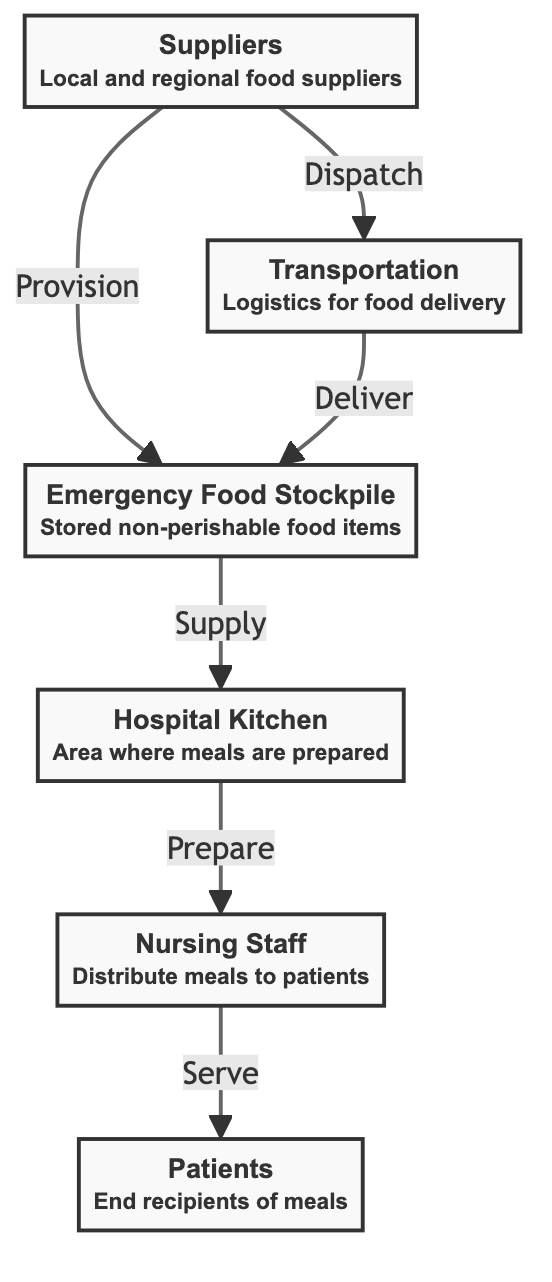What is the first step in the emergency food supply chain? The first step in the emergency food supply chain is the "Emergency Food Stockpile," where non-perishable food items are stored. This is represented as node 1 in the diagram.
Answer: Emergency Food Stockpile How many nodes are there in the diagram? The diagram contains a total of six nodes, which are: Emergency Food Stockpile, Suppliers, Transportation, Hospital Kitchen, Nursing Staff, and Patients.
Answer: 6 What role do local and regional food suppliers play in the chain? Local and regional food suppliers are responsible for the provision of food to the emergency food stockpile, as indicated by the arrow showing the provision relationship between node 2 (Suppliers) and node 1 (Emergency Food Stockpile).
Answer: Provision Which node directly supplies meals to the hospital kitchen? The node that directly supplies meals to the hospital kitchen is the "Emergency Food Stockpile," as indicated by the arrow showing the supply relationship between node 1 and node 4 (Hospital Kitchen).
Answer: Emergency Food Stockpile How do meals reach the patients? Meals reach patients through the series of actions initiated in the hospital kitchen, where meals are prepared and then served by the nursing staff, illustrating the flow from node 4 (Hospital Kitchen) to node 5 (Nursing Staff) to node 6 (Patients).
Answer: Serve What is the relationship between suppliers and transportation? The relationship between suppliers and transportation is characterized by the dispatch action, indicating that the suppliers are responsible for dispatching food to the transportation node to facilitate delivery. This is shown by the arrow from node 2 (Suppliers) to node 3 (Transportation).
Answer: Dispatch What happens after meals are prepared in the hospital kitchen? After meals are prepared in the hospital kitchen, the nursing staff takes responsibility for serving these meals to the patients, which shows a direct flow from node 4 (Hospital Kitchen) to node 5 (Nursing Staff).
Answer: Serve Which entity is responsible for delivering food items? The entity responsible for delivering food items is the transportation node, which is highlighted by the role of logistics in food delivery as per the diagram. This is indicated by the arrow showing the delivery relationship from node 3 (Transportation) to node 1 (Emergency Food Stockpile).
Answer: Transportation 